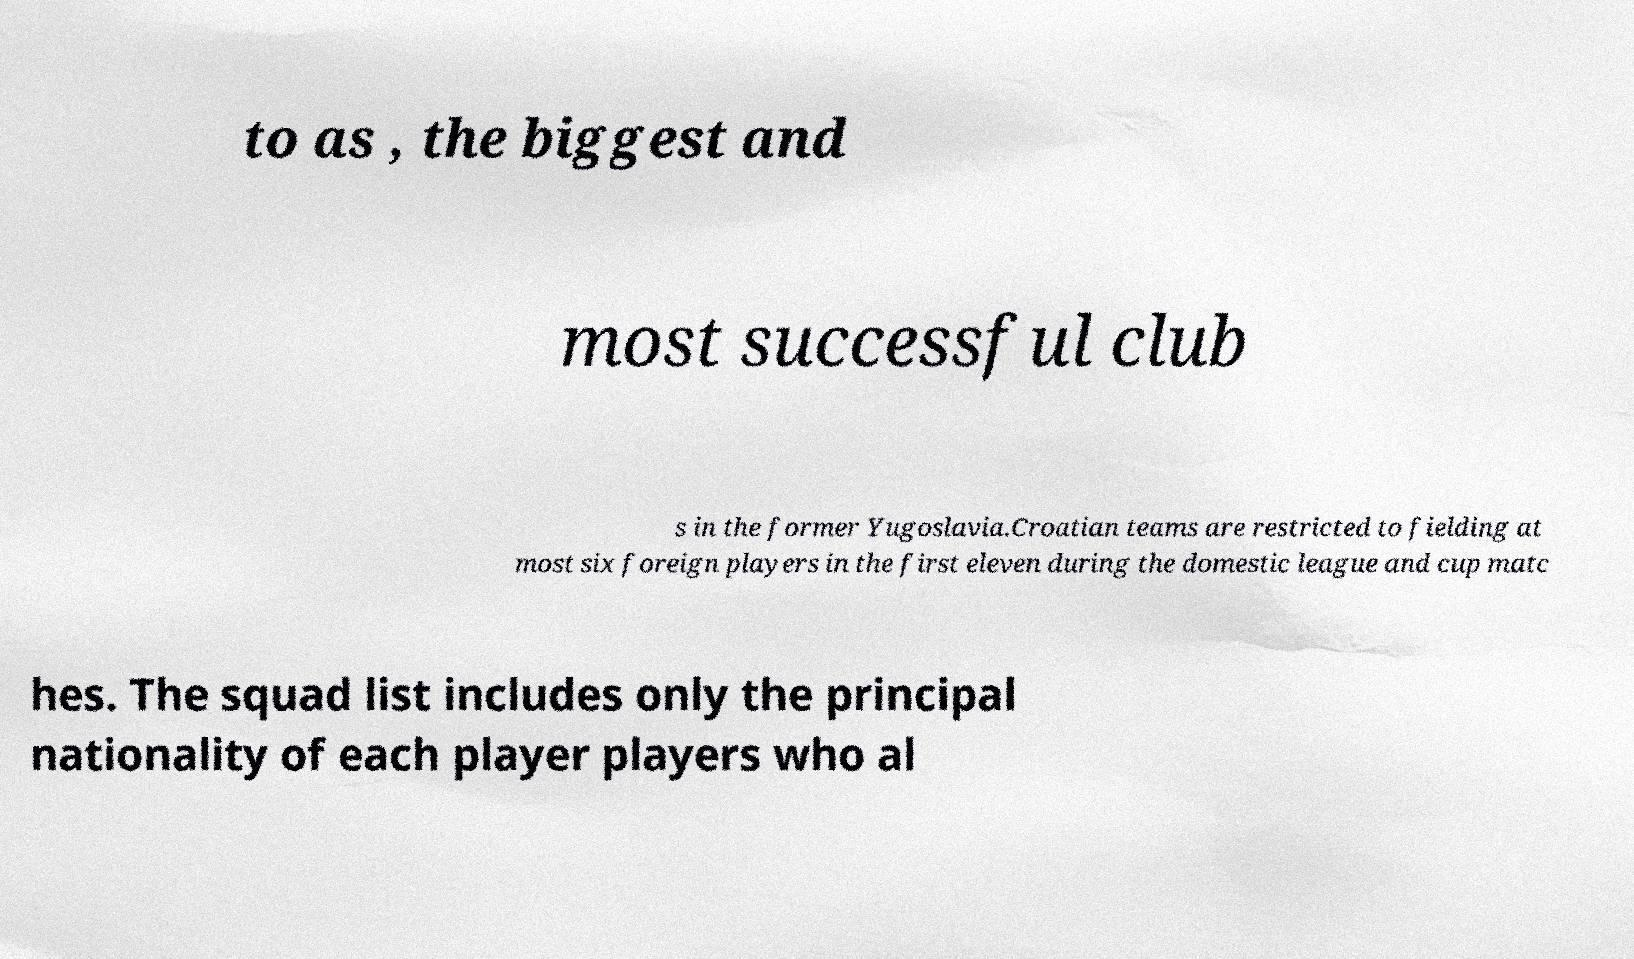Please read and relay the text visible in this image. What does it say? to as , the biggest and most successful club s in the former Yugoslavia.Croatian teams are restricted to fielding at most six foreign players in the first eleven during the domestic league and cup matc hes. The squad list includes only the principal nationality of each player players who al 